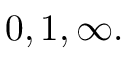<formula> <loc_0><loc_0><loc_500><loc_500>0 , 1 , \infty .</formula> 